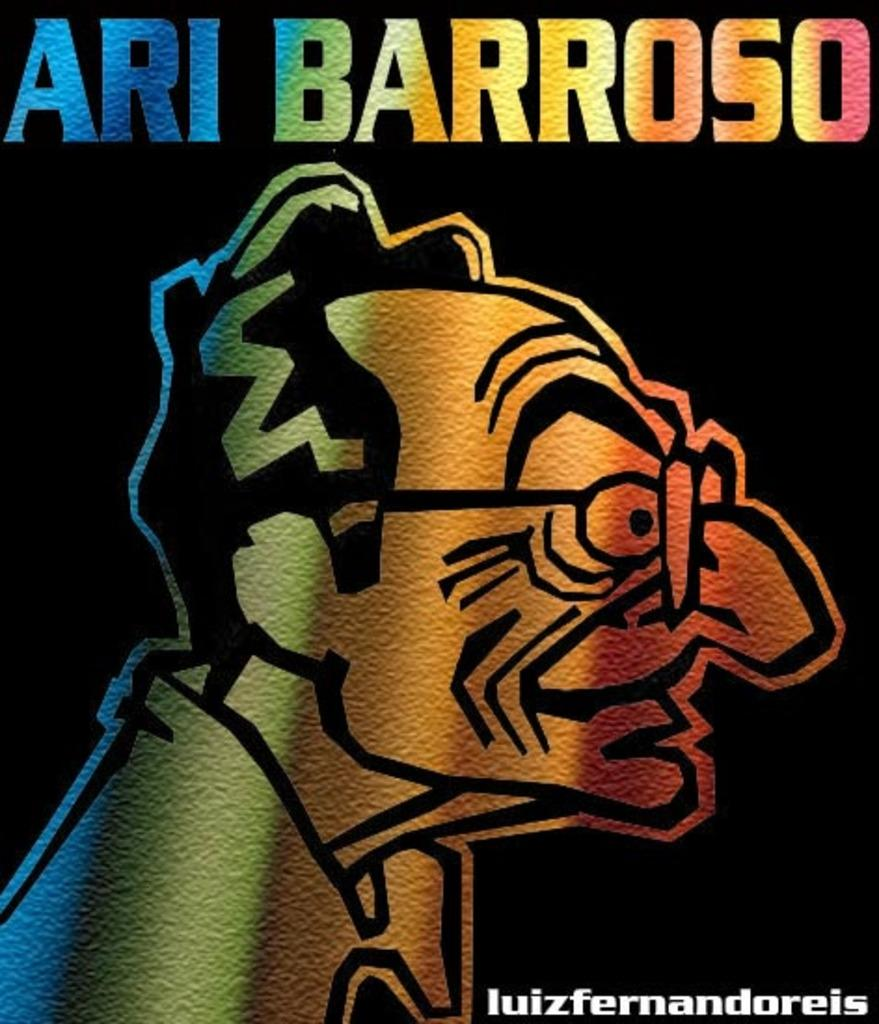<image>
Share a concise interpretation of the image provided. Color spectrum art against a black background with a cartoon charicature of a profile of a man with glasses by Ari Barroso 